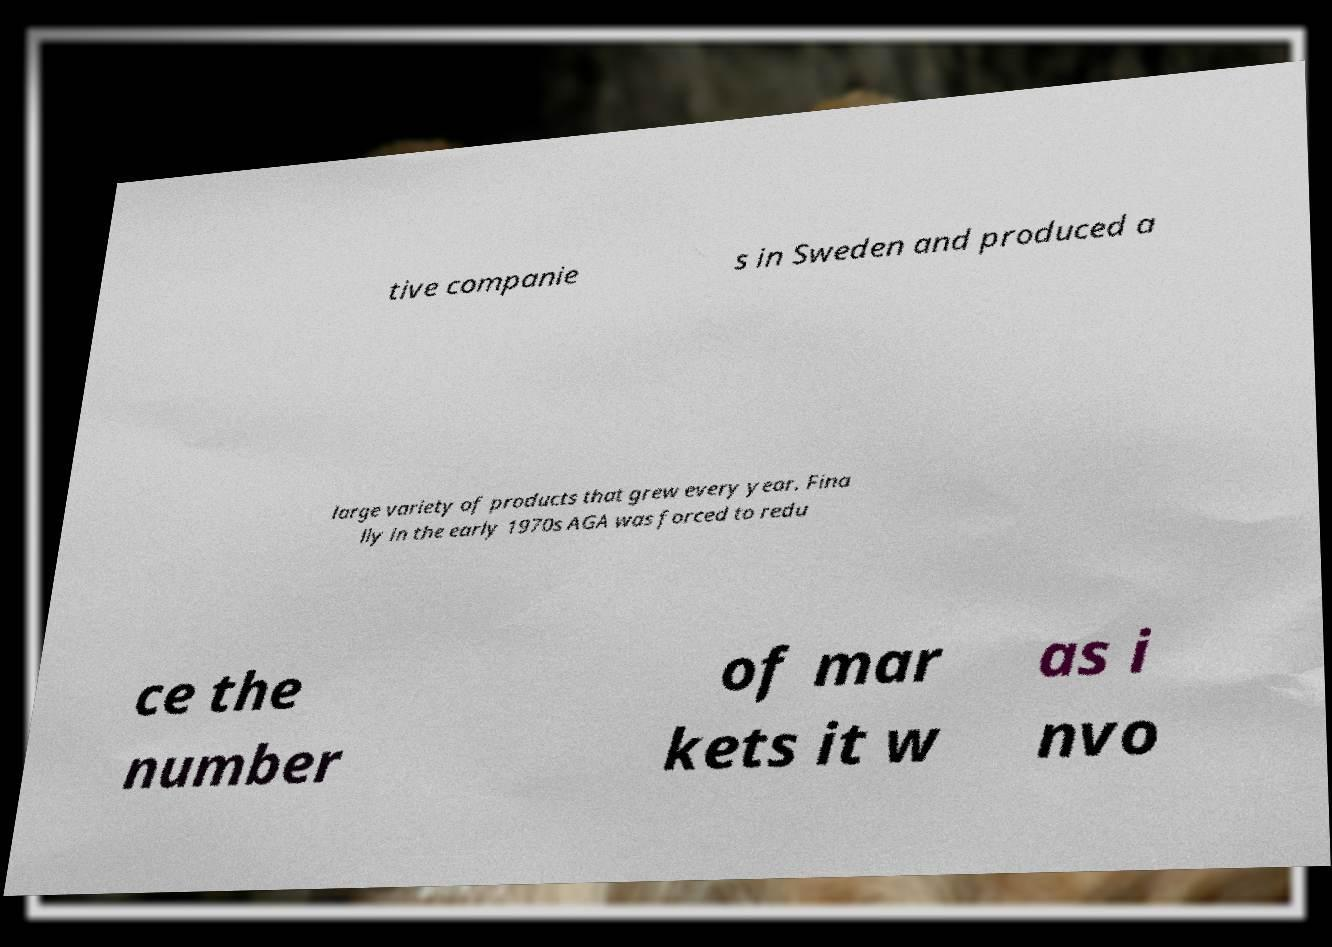What messages or text are displayed in this image? I need them in a readable, typed format. tive companie s in Sweden and produced a large variety of products that grew every year. Fina lly in the early 1970s AGA was forced to redu ce the number of mar kets it w as i nvo 